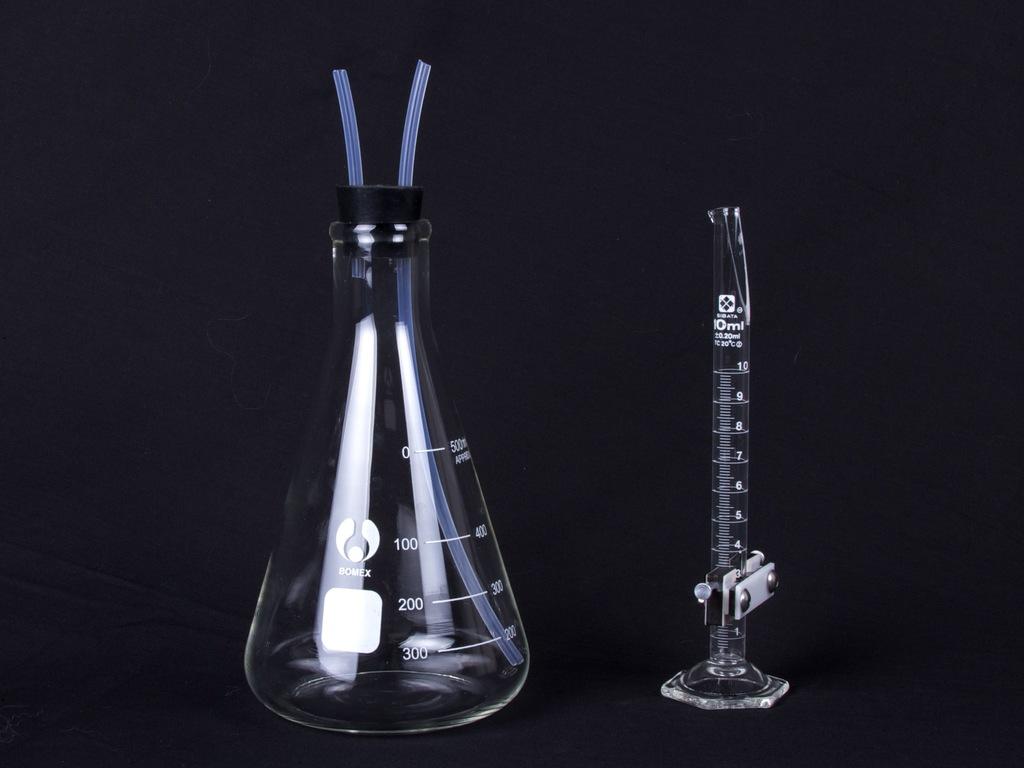What does the number at the bottom of the glass?
Your answer should be very brief. 300. 